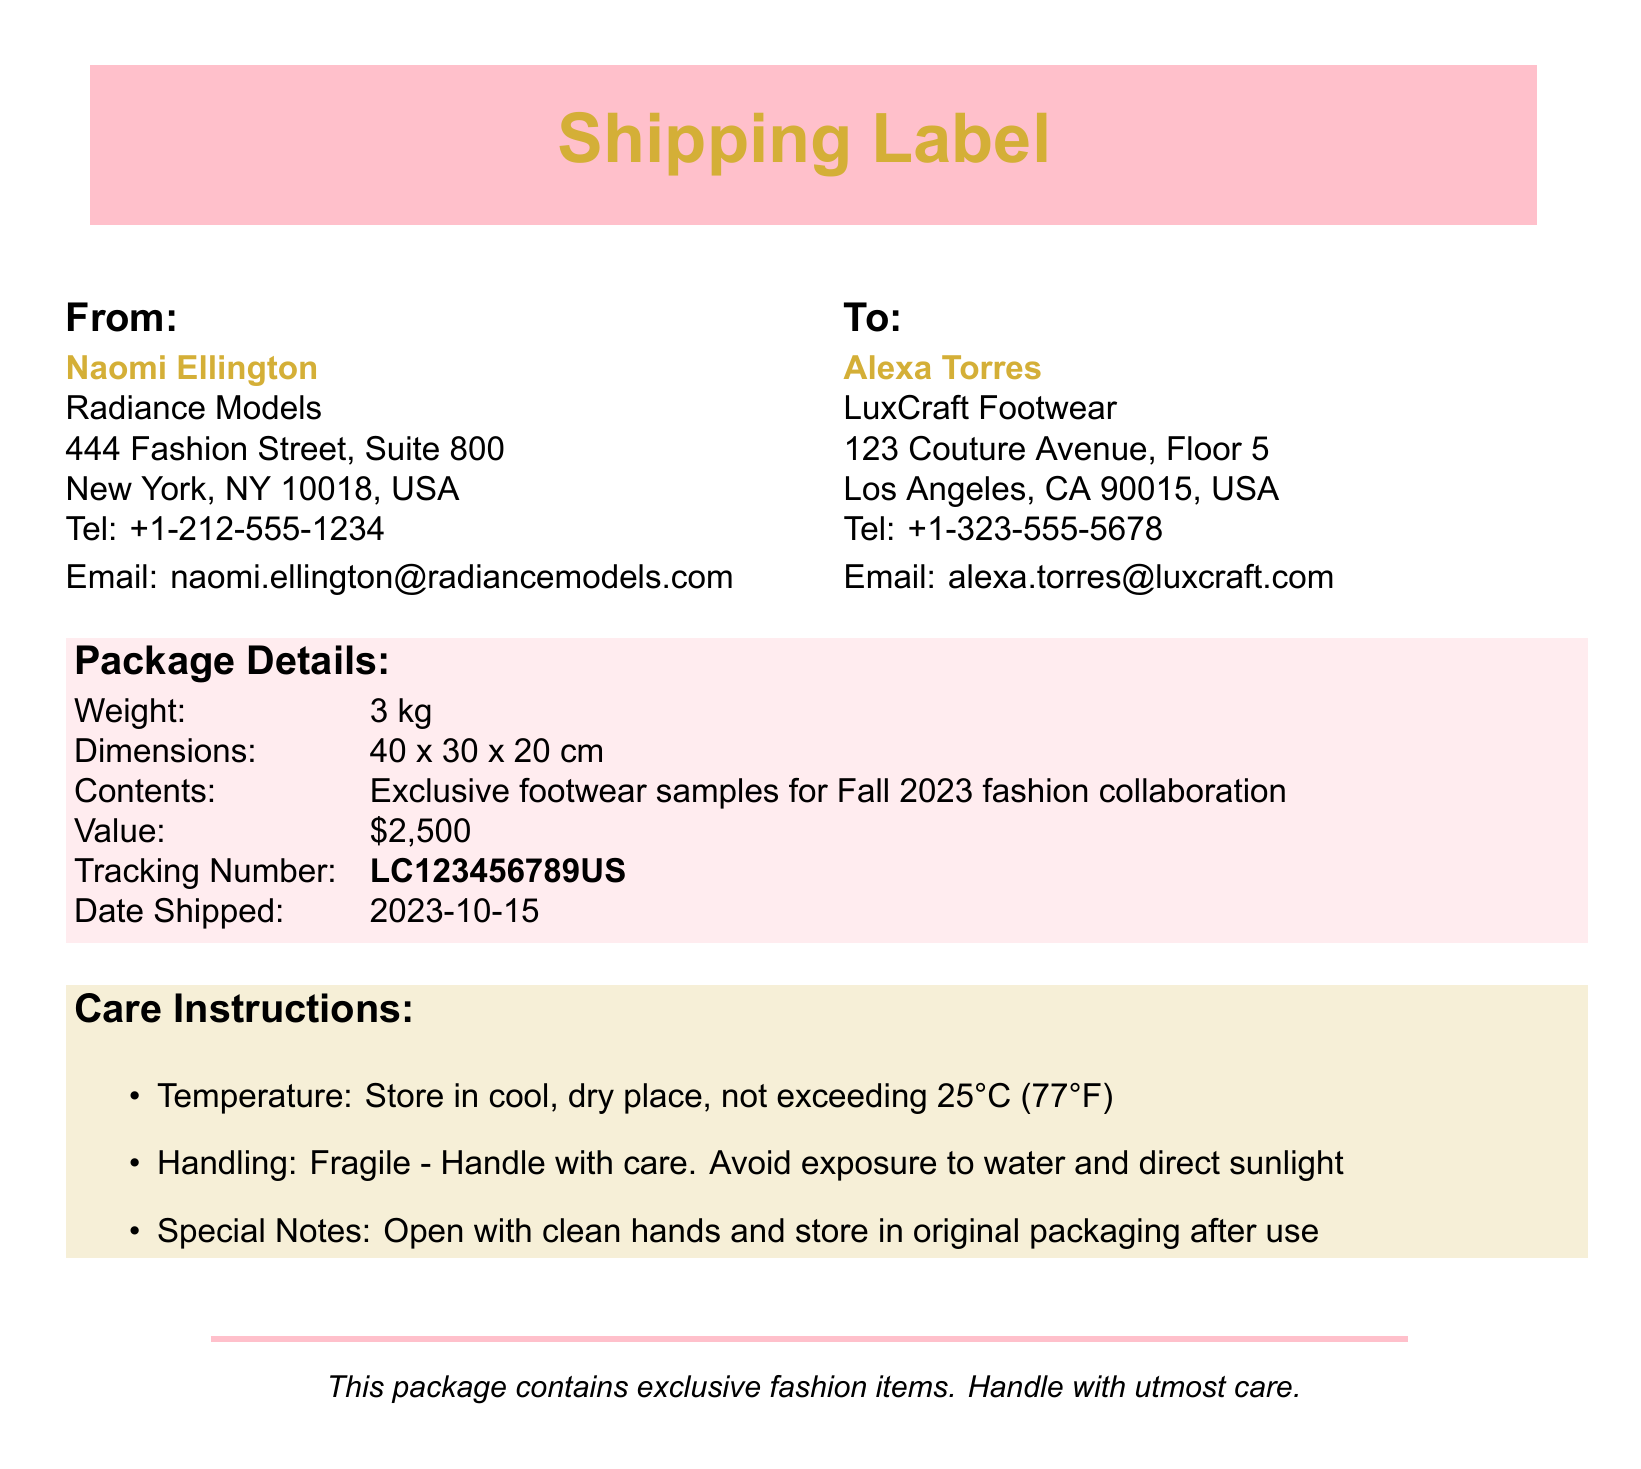what is the sender's name? The sender's name is stated in the document, and it is Naomi Ellington.
Answer: Naomi Ellington what is the recipient's address? The address of the recipient is detailed in the document as 123 Couture Avenue, Floor 5, Los Angeles, CA 90015, USA.
Answer: 123 Couture Avenue, Floor 5, Los Angeles, CA 90015, USA what is the weight of the package? The weight of the package is specifically mentioned in the details section.
Answer: 3 kg what is the value of the contents? The value of the contents is explicitly stated in the document.
Answer: $2,500 when was the package shipped? The shipping date is listed in the document.
Answer: 2023-10-15 what temperature should the items be stored at? The temperature for storage is indicated in the care instructions section.
Answer: 25°C (77°F) how should the package be handled according to the care instructions? The care instructions emphasize that the package is fragile and should be handled with care.
Answer: Fragile - Handle with care what is the tracking number? The tracking number for the shipment is provided directly in the document.
Answer: LC123456789US what should you do after opening the package? The care instructions specify a handling note regarding after opening.
Answer: Store in original packaging after use 